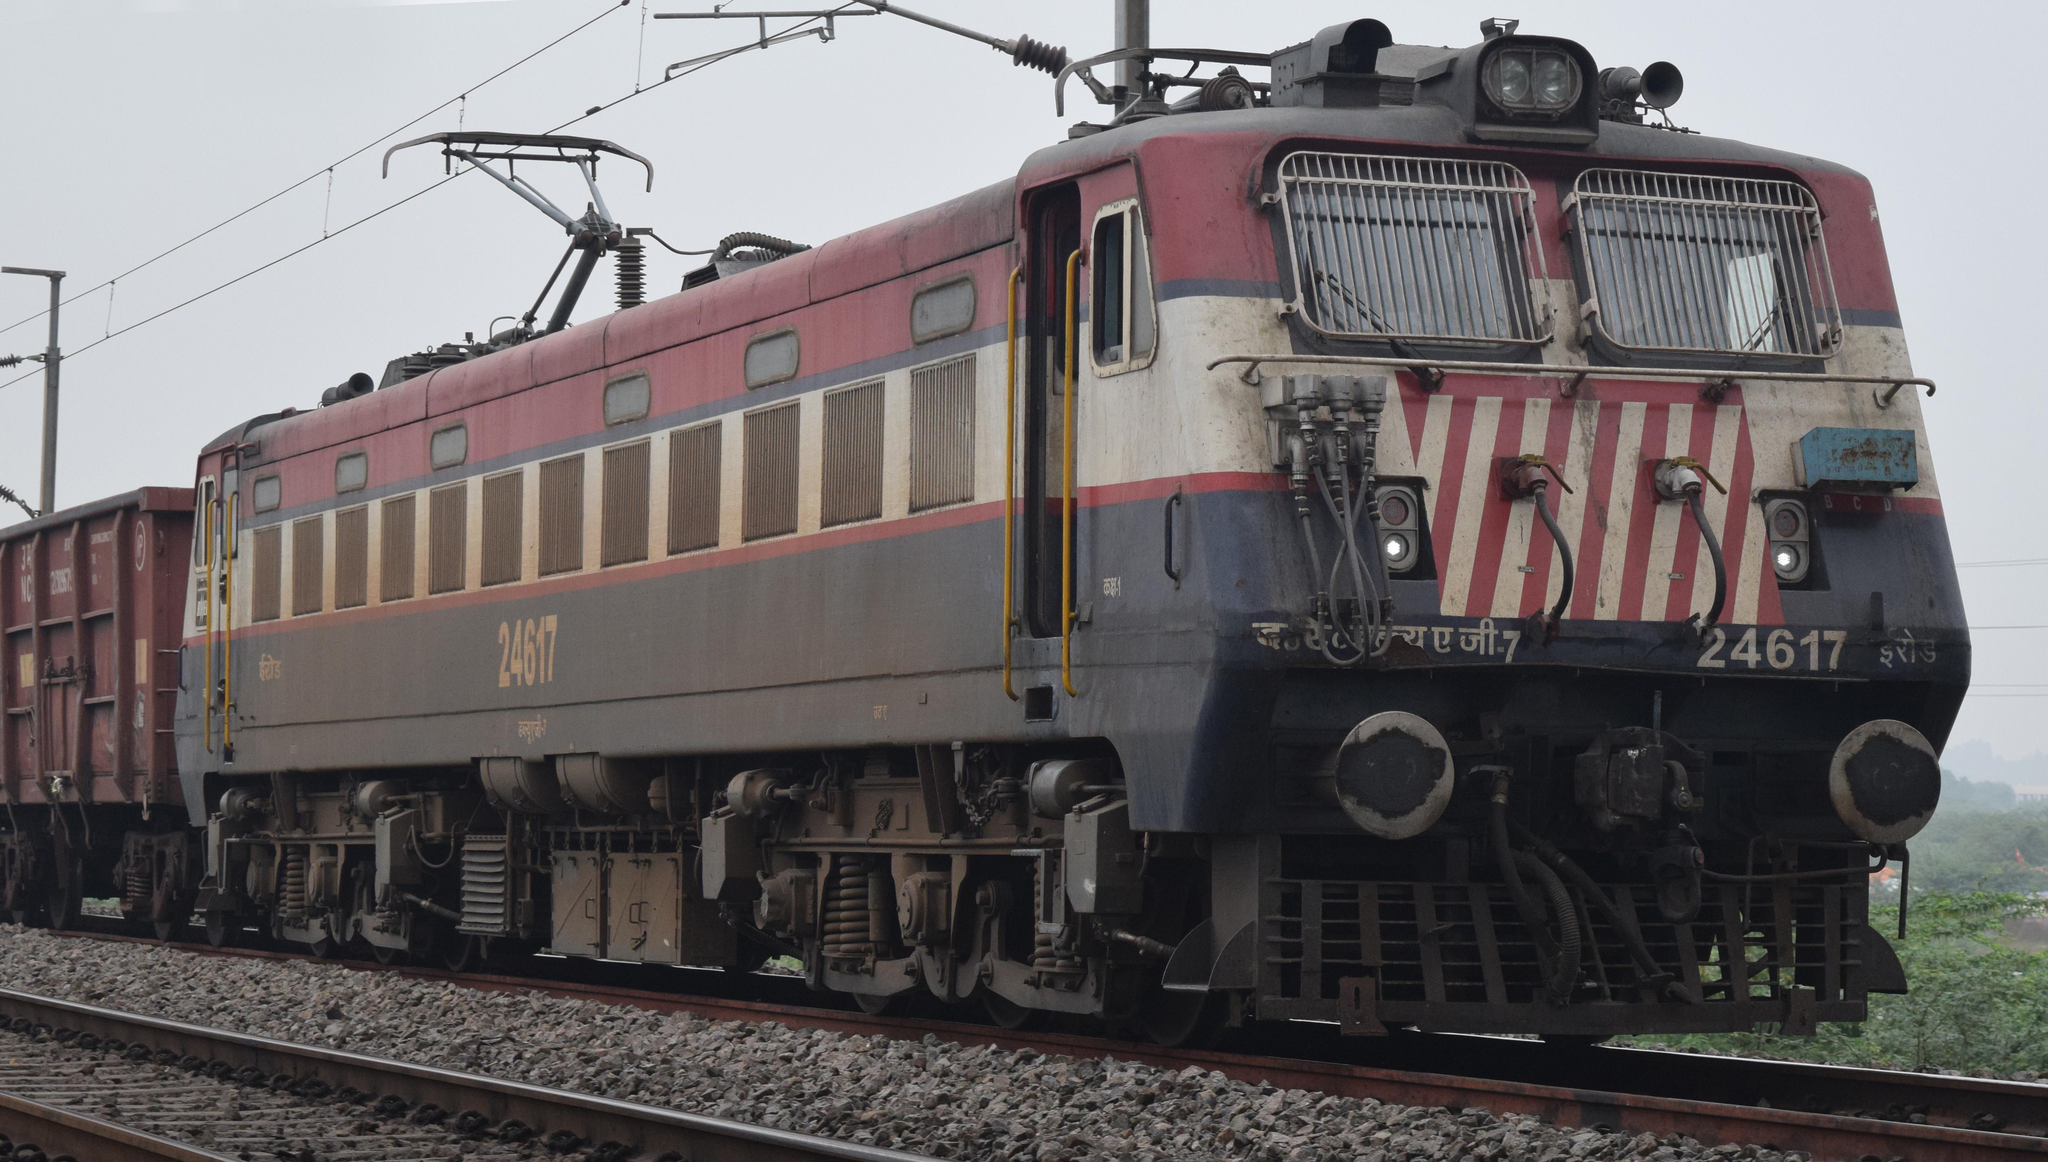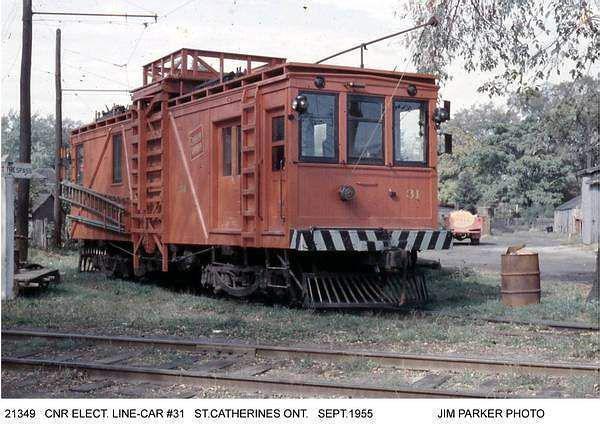The first image is the image on the left, the second image is the image on the right. Given the left and right images, does the statement "There is a blue train facing right." hold true? Answer yes or no. No. The first image is the image on the left, the second image is the image on the right. Considering the images on both sides, is "A train with three windows across the front is angled so it points right." valid? Answer yes or no. Yes. 